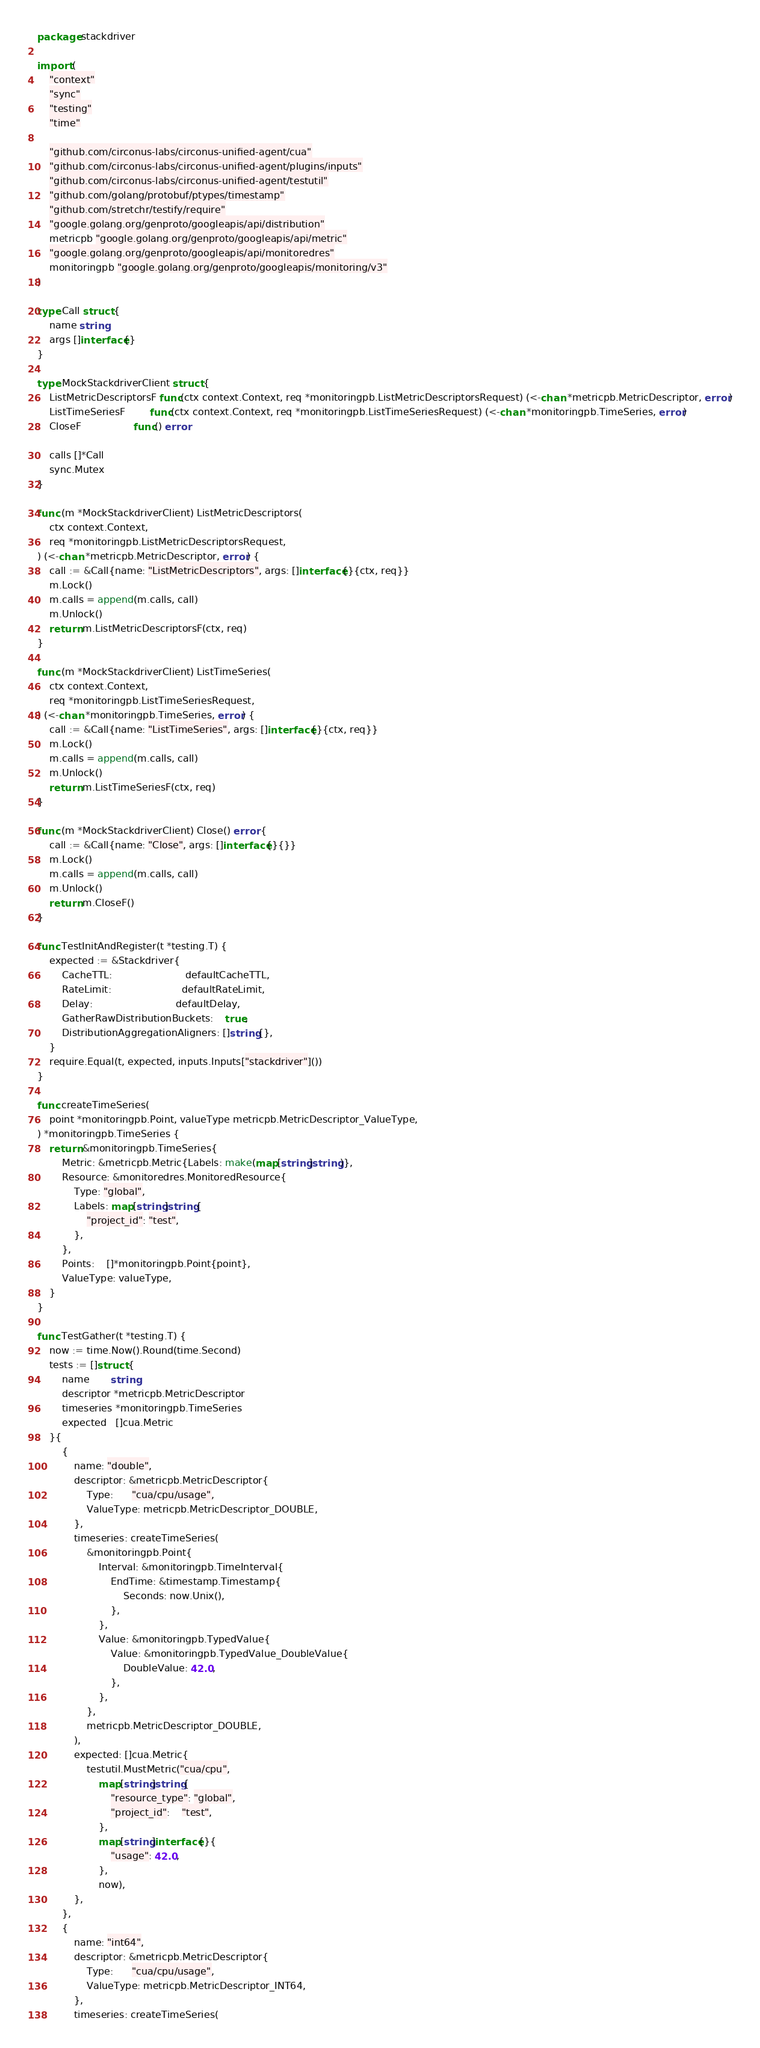<code> <loc_0><loc_0><loc_500><loc_500><_Go_>package stackdriver

import (
	"context"
	"sync"
	"testing"
	"time"

	"github.com/circonus-labs/circonus-unified-agent/cua"
	"github.com/circonus-labs/circonus-unified-agent/plugins/inputs"
	"github.com/circonus-labs/circonus-unified-agent/testutil"
	"github.com/golang/protobuf/ptypes/timestamp"
	"github.com/stretchr/testify/require"
	"google.golang.org/genproto/googleapis/api/distribution"
	metricpb "google.golang.org/genproto/googleapis/api/metric"
	"google.golang.org/genproto/googleapis/api/monitoredres"
	monitoringpb "google.golang.org/genproto/googleapis/monitoring/v3"
)

type Call struct {
	name string
	args []interface{}
}

type MockStackdriverClient struct {
	ListMetricDescriptorsF func(ctx context.Context, req *monitoringpb.ListMetricDescriptorsRequest) (<-chan *metricpb.MetricDescriptor, error)
	ListTimeSeriesF        func(ctx context.Context, req *monitoringpb.ListTimeSeriesRequest) (<-chan *monitoringpb.TimeSeries, error)
	CloseF                 func() error

	calls []*Call
	sync.Mutex
}

func (m *MockStackdriverClient) ListMetricDescriptors(
	ctx context.Context,
	req *monitoringpb.ListMetricDescriptorsRequest,
) (<-chan *metricpb.MetricDescriptor, error) {
	call := &Call{name: "ListMetricDescriptors", args: []interface{}{ctx, req}}
	m.Lock()
	m.calls = append(m.calls, call)
	m.Unlock()
	return m.ListMetricDescriptorsF(ctx, req)
}

func (m *MockStackdriverClient) ListTimeSeries(
	ctx context.Context,
	req *monitoringpb.ListTimeSeriesRequest,
) (<-chan *monitoringpb.TimeSeries, error) {
	call := &Call{name: "ListTimeSeries", args: []interface{}{ctx, req}}
	m.Lock()
	m.calls = append(m.calls, call)
	m.Unlock()
	return m.ListTimeSeriesF(ctx, req)
}

func (m *MockStackdriverClient) Close() error {
	call := &Call{name: "Close", args: []interface{}{}}
	m.Lock()
	m.calls = append(m.calls, call)
	m.Unlock()
	return m.CloseF()
}

func TestInitAndRegister(t *testing.T) {
	expected := &Stackdriver{
		CacheTTL:                        defaultCacheTTL,
		RateLimit:                       defaultRateLimit,
		Delay:                           defaultDelay,
		GatherRawDistributionBuckets:    true,
		DistributionAggregationAligners: []string{},
	}
	require.Equal(t, expected, inputs.Inputs["stackdriver"]())
}

func createTimeSeries(
	point *monitoringpb.Point, valueType metricpb.MetricDescriptor_ValueType,
) *monitoringpb.TimeSeries {
	return &monitoringpb.TimeSeries{
		Metric: &metricpb.Metric{Labels: make(map[string]string)},
		Resource: &monitoredres.MonitoredResource{
			Type: "global",
			Labels: map[string]string{
				"project_id": "test",
			},
		},
		Points:    []*monitoringpb.Point{point},
		ValueType: valueType,
	}
}

func TestGather(t *testing.T) {
	now := time.Now().Round(time.Second)
	tests := []struct {
		name       string
		descriptor *metricpb.MetricDescriptor
		timeseries *monitoringpb.TimeSeries
		expected   []cua.Metric
	}{
		{
			name: "double",
			descriptor: &metricpb.MetricDescriptor{
				Type:      "cua/cpu/usage",
				ValueType: metricpb.MetricDescriptor_DOUBLE,
			},
			timeseries: createTimeSeries(
				&monitoringpb.Point{
					Interval: &monitoringpb.TimeInterval{
						EndTime: &timestamp.Timestamp{
							Seconds: now.Unix(),
						},
					},
					Value: &monitoringpb.TypedValue{
						Value: &monitoringpb.TypedValue_DoubleValue{
							DoubleValue: 42.0,
						},
					},
				},
				metricpb.MetricDescriptor_DOUBLE,
			),
			expected: []cua.Metric{
				testutil.MustMetric("cua/cpu",
					map[string]string{
						"resource_type": "global",
						"project_id":    "test",
					},
					map[string]interface{}{
						"usage": 42.0,
					},
					now),
			},
		},
		{
			name: "int64",
			descriptor: &metricpb.MetricDescriptor{
				Type:      "cua/cpu/usage",
				ValueType: metricpb.MetricDescriptor_INT64,
			},
			timeseries: createTimeSeries(</code> 